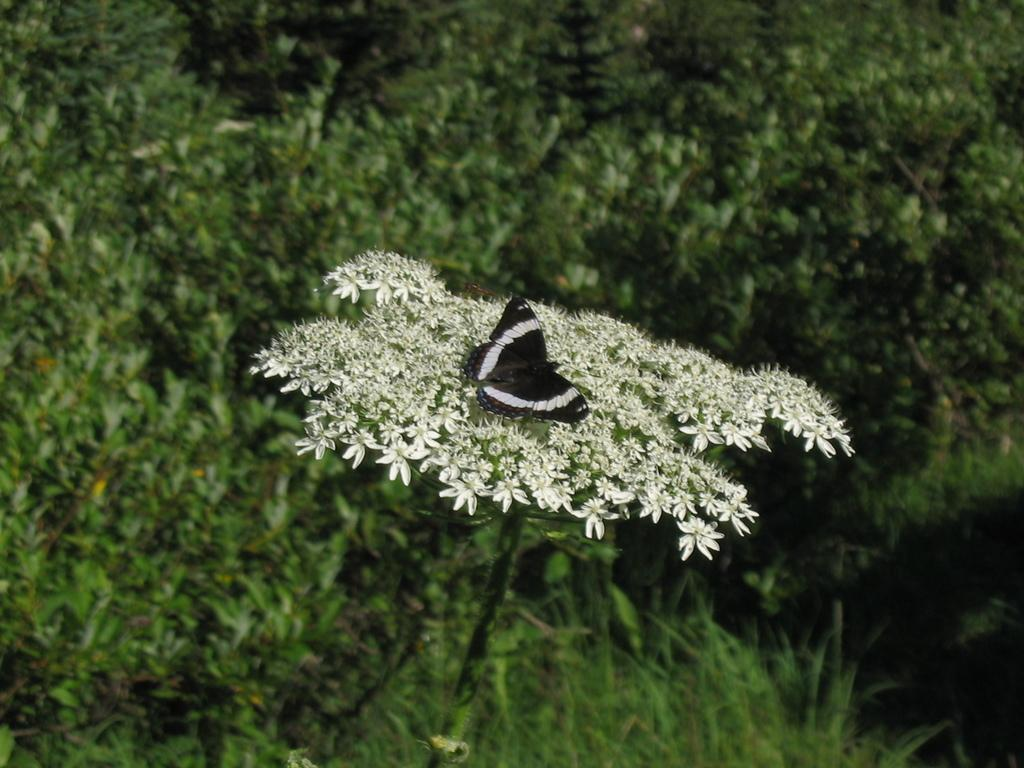Where was the image most likely taken? The image was likely clicked outside. What is the main subject of the image? There is a black color butterfly in the center of the image. What is the butterfly resting on? The butterfly is on white color flowers. What can be seen in the background of the image? There is green grass and plants visible in the background of the image. What sound does the butterfly make in the image? Butterflies do not make sounds, so there is no sound to be heard in the image. How do you care for the fang in the image? There is no fang present in the image; it features a black butterfly on white flowers. 